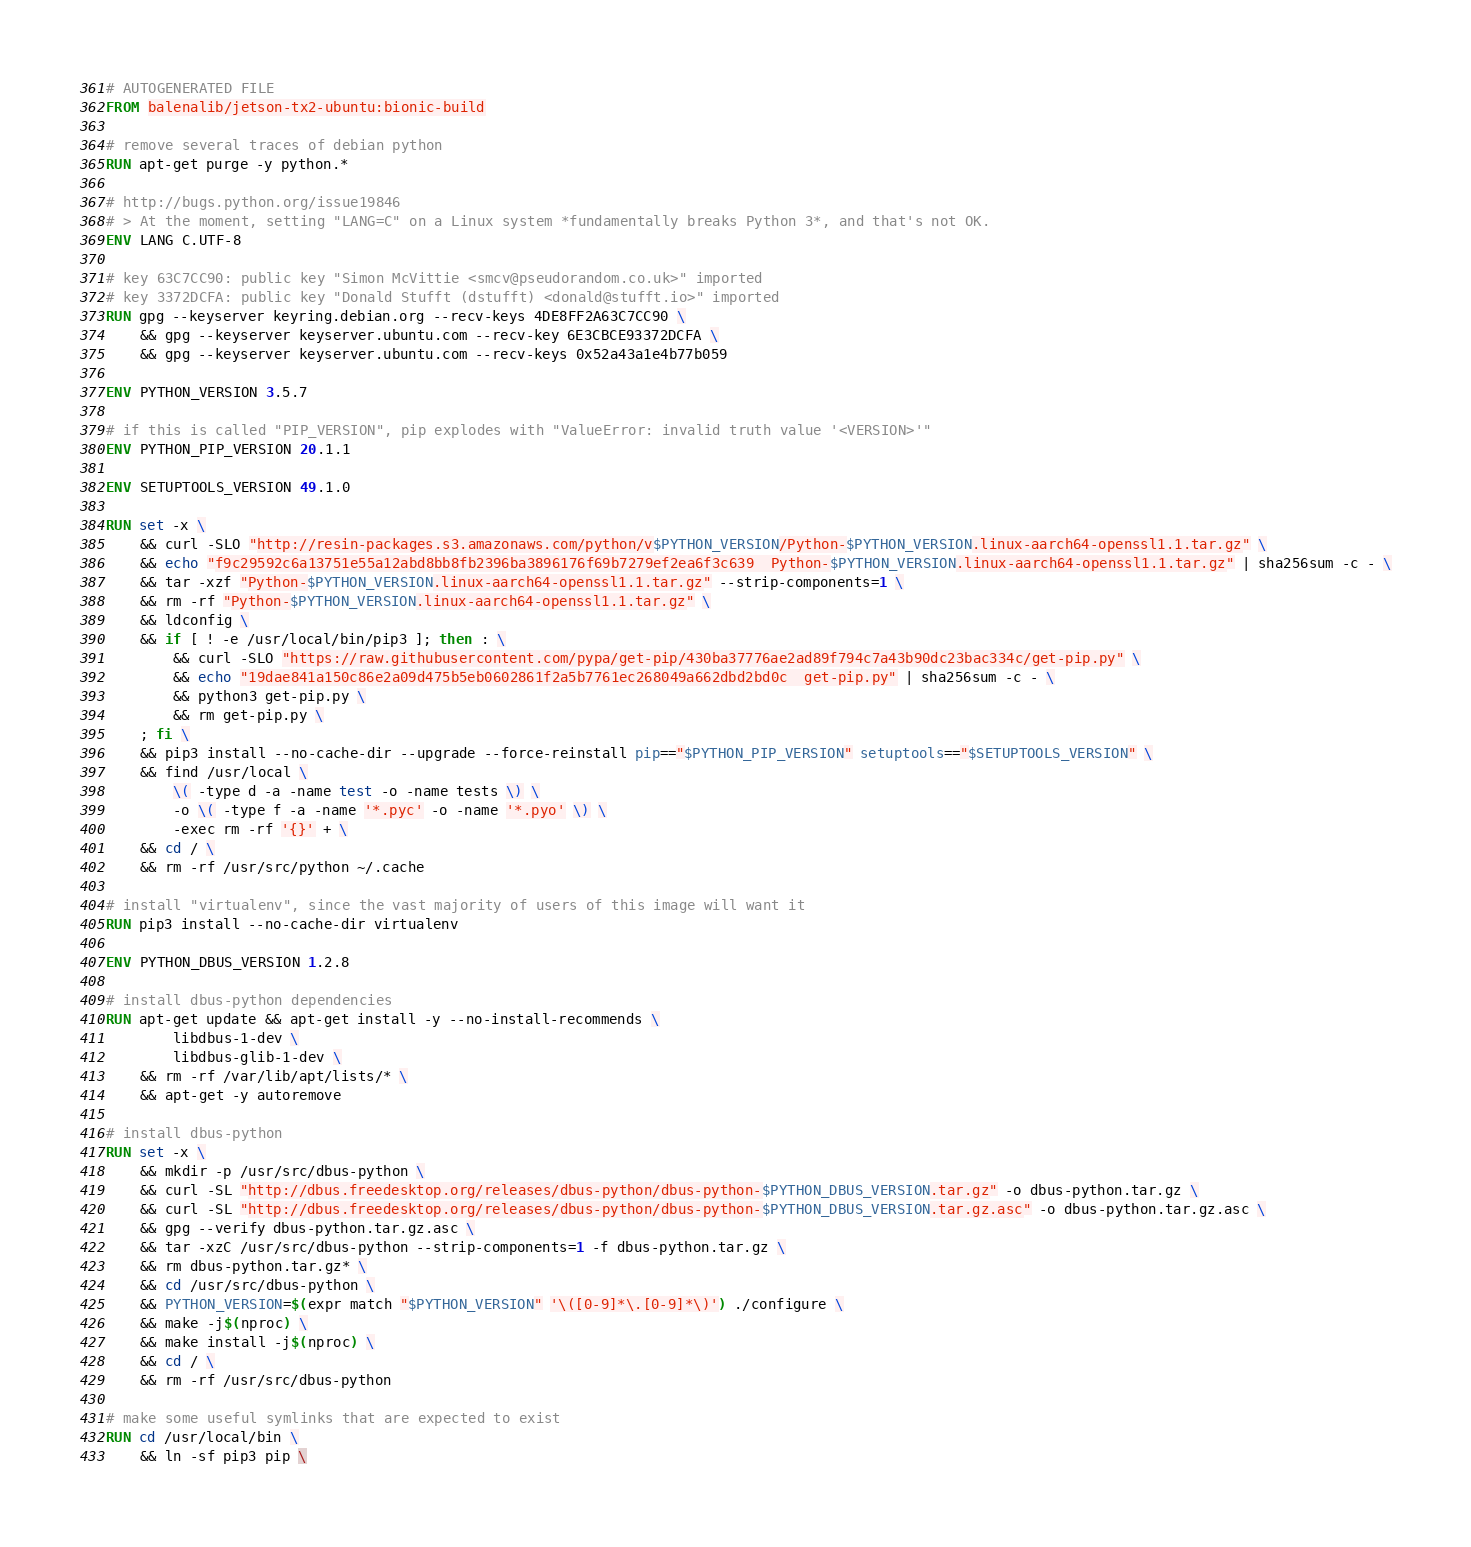<code> <loc_0><loc_0><loc_500><loc_500><_Dockerfile_># AUTOGENERATED FILE
FROM balenalib/jetson-tx2-ubuntu:bionic-build

# remove several traces of debian python
RUN apt-get purge -y python.*

# http://bugs.python.org/issue19846
# > At the moment, setting "LANG=C" on a Linux system *fundamentally breaks Python 3*, and that's not OK.
ENV LANG C.UTF-8

# key 63C7CC90: public key "Simon McVittie <smcv@pseudorandom.co.uk>" imported
# key 3372DCFA: public key "Donald Stufft (dstufft) <donald@stufft.io>" imported
RUN gpg --keyserver keyring.debian.org --recv-keys 4DE8FF2A63C7CC90 \
	&& gpg --keyserver keyserver.ubuntu.com --recv-key 6E3CBCE93372DCFA \
	&& gpg --keyserver keyserver.ubuntu.com --recv-keys 0x52a43a1e4b77b059

ENV PYTHON_VERSION 3.5.7

# if this is called "PIP_VERSION", pip explodes with "ValueError: invalid truth value '<VERSION>'"
ENV PYTHON_PIP_VERSION 20.1.1

ENV SETUPTOOLS_VERSION 49.1.0

RUN set -x \
	&& curl -SLO "http://resin-packages.s3.amazonaws.com/python/v$PYTHON_VERSION/Python-$PYTHON_VERSION.linux-aarch64-openssl1.1.tar.gz" \
	&& echo "f9c29592c6a13751e55a12abd8bb8fb2396ba3896176f69b7279ef2ea6f3c639  Python-$PYTHON_VERSION.linux-aarch64-openssl1.1.tar.gz" | sha256sum -c - \
	&& tar -xzf "Python-$PYTHON_VERSION.linux-aarch64-openssl1.1.tar.gz" --strip-components=1 \
	&& rm -rf "Python-$PYTHON_VERSION.linux-aarch64-openssl1.1.tar.gz" \
	&& ldconfig \
	&& if [ ! -e /usr/local/bin/pip3 ]; then : \
		&& curl -SLO "https://raw.githubusercontent.com/pypa/get-pip/430ba37776ae2ad89f794c7a43b90dc23bac334c/get-pip.py" \
		&& echo "19dae841a150c86e2a09d475b5eb0602861f2a5b7761ec268049a662dbd2bd0c  get-pip.py" | sha256sum -c - \
		&& python3 get-pip.py \
		&& rm get-pip.py \
	; fi \
	&& pip3 install --no-cache-dir --upgrade --force-reinstall pip=="$PYTHON_PIP_VERSION" setuptools=="$SETUPTOOLS_VERSION" \
	&& find /usr/local \
		\( -type d -a -name test -o -name tests \) \
		-o \( -type f -a -name '*.pyc' -o -name '*.pyo' \) \
		-exec rm -rf '{}' + \
	&& cd / \
	&& rm -rf /usr/src/python ~/.cache

# install "virtualenv", since the vast majority of users of this image will want it
RUN pip3 install --no-cache-dir virtualenv

ENV PYTHON_DBUS_VERSION 1.2.8

# install dbus-python dependencies 
RUN apt-get update && apt-get install -y --no-install-recommends \
		libdbus-1-dev \
		libdbus-glib-1-dev \
	&& rm -rf /var/lib/apt/lists/* \
	&& apt-get -y autoremove

# install dbus-python
RUN set -x \
	&& mkdir -p /usr/src/dbus-python \
	&& curl -SL "http://dbus.freedesktop.org/releases/dbus-python/dbus-python-$PYTHON_DBUS_VERSION.tar.gz" -o dbus-python.tar.gz \
	&& curl -SL "http://dbus.freedesktop.org/releases/dbus-python/dbus-python-$PYTHON_DBUS_VERSION.tar.gz.asc" -o dbus-python.tar.gz.asc \
	&& gpg --verify dbus-python.tar.gz.asc \
	&& tar -xzC /usr/src/dbus-python --strip-components=1 -f dbus-python.tar.gz \
	&& rm dbus-python.tar.gz* \
	&& cd /usr/src/dbus-python \
	&& PYTHON_VERSION=$(expr match "$PYTHON_VERSION" '\([0-9]*\.[0-9]*\)') ./configure \
	&& make -j$(nproc) \
	&& make install -j$(nproc) \
	&& cd / \
	&& rm -rf /usr/src/dbus-python

# make some useful symlinks that are expected to exist
RUN cd /usr/local/bin \
	&& ln -sf pip3 pip \</code> 